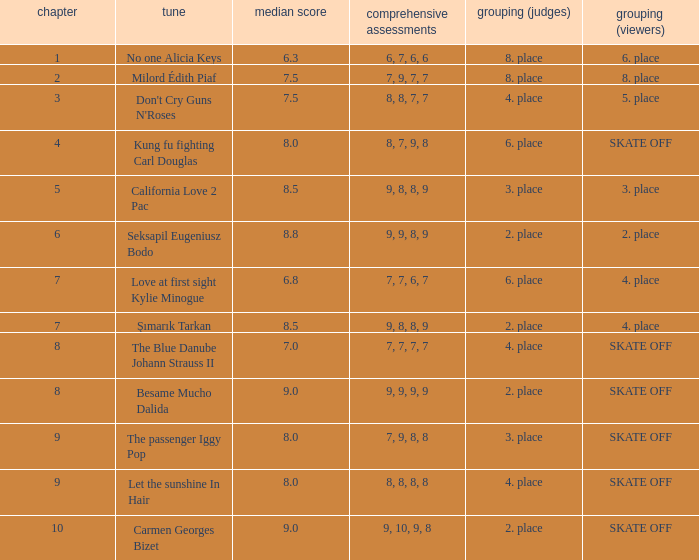Would you mind parsing the complete table? {'header': ['chapter', 'tune', 'median score', 'comprehensive assessments', 'grouping (judges)', 'grouping (viewers)'], 'rows': [['1', 'No one Alicia Keys', '6.3', '6, 7, 6, 6', '8. place', '6. place'], ['2', 'Milord Édith Piaf', '7.5', '7, 9, 7, 7', '8. place', '8. place'], ['3', "Don't Cry Guns N'Roses", '7.5', '8, 8, 7, 7', '4. place', '5. place'], ['4', 'Kung fu fighting Carl Douglas', '8.0', '8, 7, 9, 8', '6. place', 'SKATE OFF'], ['5', 'California Love 2 Pac', '8.5', '9, 8, 8, 9', '3. place', '3. place'], ['6', 'Seksapil Eugeniusz Bodo', '8.8', '9, 9, 8, 9', '2. place', '2. place'], ['7', 'Love at first sight Kylie Minogue', '6.8', '7, 7, 6, 7', '6. place', '4. place'], ['7', 'Şımarık Tarkan', '8.5', '9, 8, 8, 9', '2. place', '4. place'], ['8', 'The Blue Danube Johann Strauss II', '7.0', '7, 7, 7, 7', '4. place', 'SKATE OFF'], ['8', 'Besame Mucho Dalida', '9.0', '9, 9, 9, 9', '2. place', 'SKATE OFF'], ['9', 'The passenger Iggy Pop', '8.0', '7, 9, 8, 8', '3. place', 'SKATE OFF'], ['9', 'Let the sunshine In Hair', '8.0', '8, 8, 8, 8', '4. place', 'SKATE OFF'], ['10', 'Carmen Georges Bizet', '9.0', '9, 10, 9, 8', '2. place', 'SKATE OFF']]} Name the classification for 9, 9, 8, 9 2. place. 